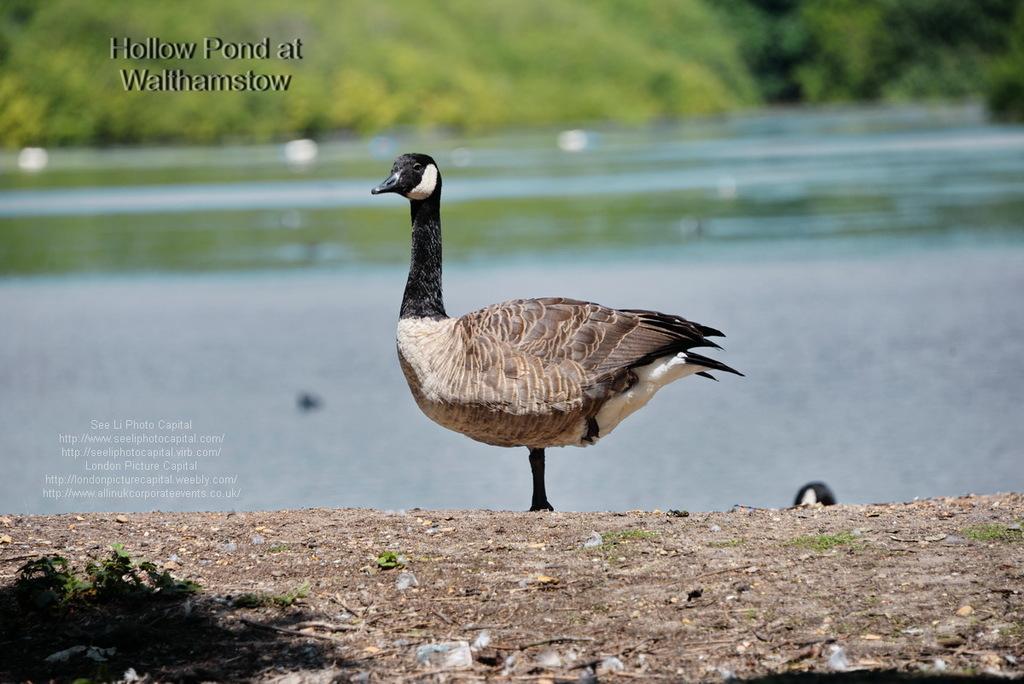In one or two sentences, can you explain what this image depicts? In the image we can see there is a duck which is standing on the ground and behind there is a water and its a poster. 